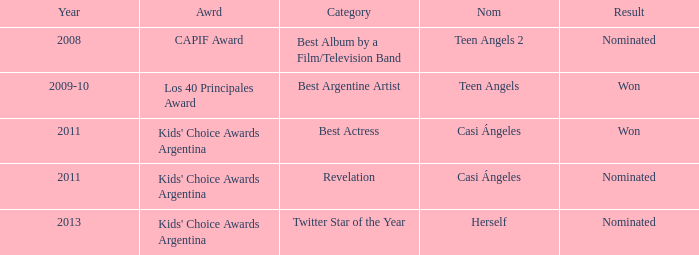What year was there a nomination for Best Actress at the Kids' Choice Awards Argentina? 2011.0. 